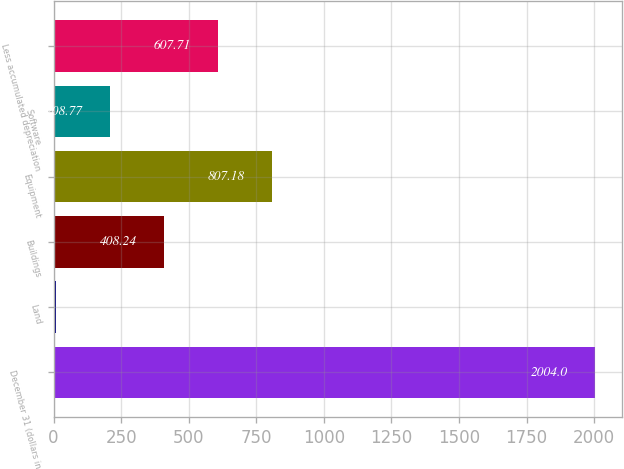Convert chart to OTSL. <chart><loc_0><loc_0><loc_500><loc_500><bar_chart><fcel>December 31 (dollars in<fcel>Land<fcel>Buildings<fcel>Equipment<fcel>Software<fcel>Less accumulated depreciation<nl><fcel>2004<fcel>9.3<fcel>408.24<fcel>807.18<fcel>208.77<fcel>607.71<nl></chart> 